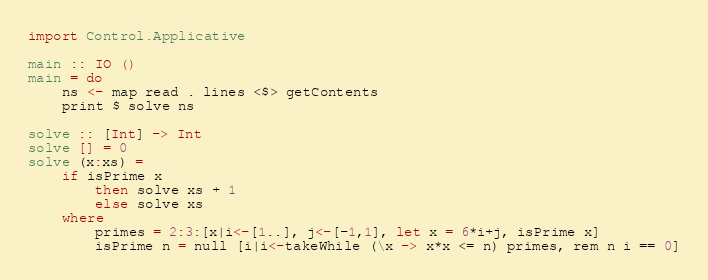<code> <loc_0><loc_0><loc_500><loc_500><_Haskell_>import Control.Applicative

main :: IO ()
main = do
    ns <- map read . lines <$> getContents
    print $ solve ns

solve :: [Int] -> Int
solve [] = 0
solve (x:xs) =
    if isPrime x
        then solve xs + 1
        else solve xs
    where
        primes = 2:3:[x|i<-[1..], j<-[-1,1], let x = 6*i+j, isPrime x]
        isPrime n = null [i|i<-takeWhile (\x -> x*x <= n) primes, rem n i == 0]</code> 